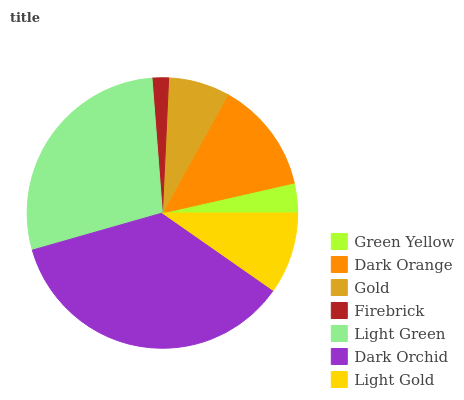Is Firebrick the minimum?
Answer yes or no. Yes. Is Dark Orchid the maximum?
Answer yes or no. Yes. Is Dark Orange the minimum?
Answer yes or no. No. Is Dark Orange the maximum?
Answer yes or no. No. Is Dark Orange greater than Green Yellow?
Answer yes or no. Yes. Is Green Yellow less than Dark Orange?
Answer yes or no. Yes. Is Green Yellow greater than Dark Orange?
Answer yes or no. No. Is Dark Orange less than Green Yellow?
Answer yes or no. No. Is Light Gold the high median?
Answer yes or no. Yes. Is Light Gold the low median?
Answer yes or no. Yes. Is Dark Orange the high median?
Answer yes or no. No. Is Dark Orange the low median?
Answer yes or no. No. 